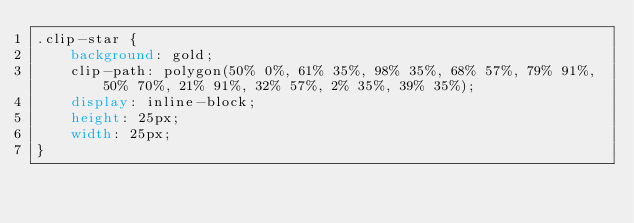Convert code to text. <code><loc_0><loc_0><loc_500><loc_500><_CSS_>.clip-star {
    background: gold;
    clip-path: polygon(50% 0%, 61% 35%, 98% 35%, 68% 57%, 79% 91%, 50% 70%, 21% 91%, 32% 57%, 2% 35%, 39% 35%);
    display: inline-block;
    height: 25px;
    width: 25px;
}
</code> 